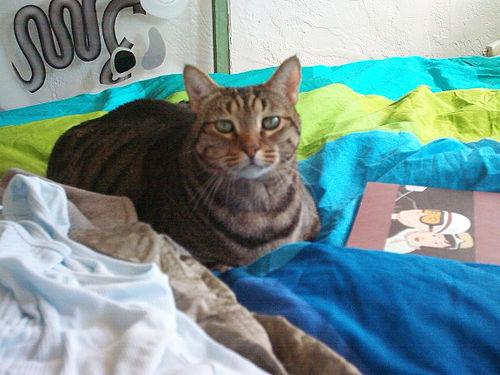Is the cat asleep?
Write a very short answer. No. Who is wearing a helmet?
Keep it brief. Book character. How many cats are there?
Give a very brief answer. 1. Does this cat have blue eyes?
Keep it brief. Yes. 